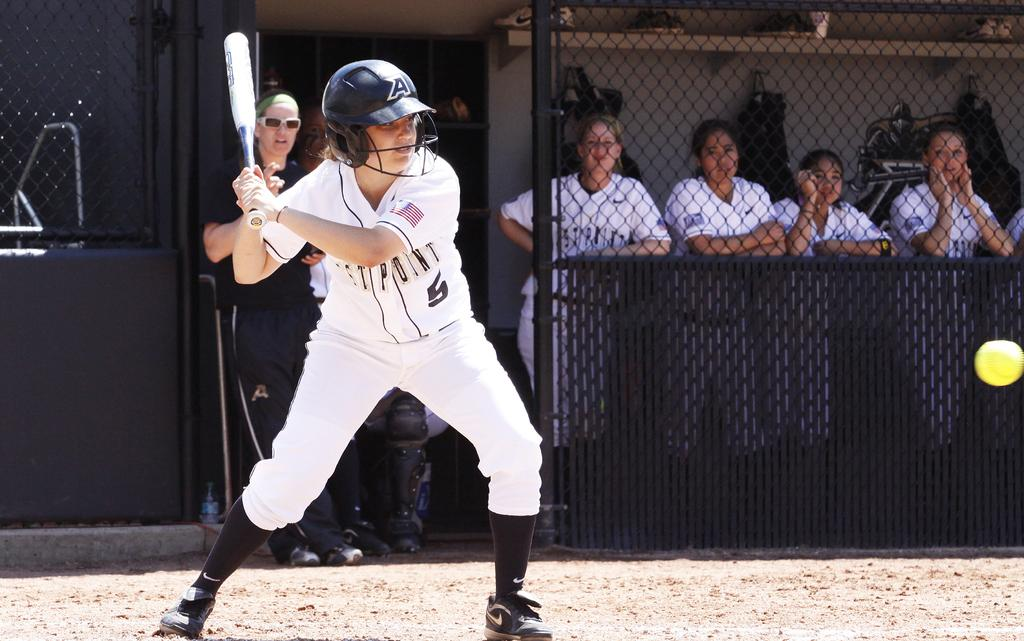<image>
Render a clear and concise summary of the photo. The batter pictured is wearing a number 5 top. 